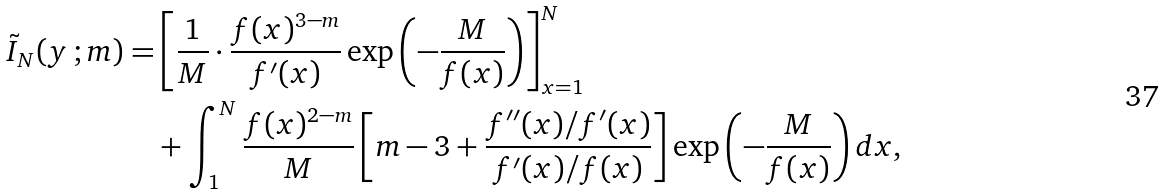Convert formula to latex. <formula><loc_0><loc_0><loc_500><loc_500>\tilde { I } _ { N } ( y \, ; m ) = & \left [ \frac { 1 } { M } \cdot \frac { f ( x ) ^ { 3 - m } } { f ^ { \prime } ( x ) } \exp \left ( - \frac { M } { f ( x ) } \right ) \right ] _ { x = 1 } ^ { N } \\ & + \int _ { 1 } ^ { N } \frac { f ( x ) ^ { 2 - m } } { M } \left [ m - 3 + \frac { f ^ { \prime \prime } ( x ) / f ^ { \prime } ( x ) } { f ^ { \prime } ( x ) / f ( x ) } \right ] \exp \left ( - \frac { M } { f ( x ) } \right ) d x ,</formula> 